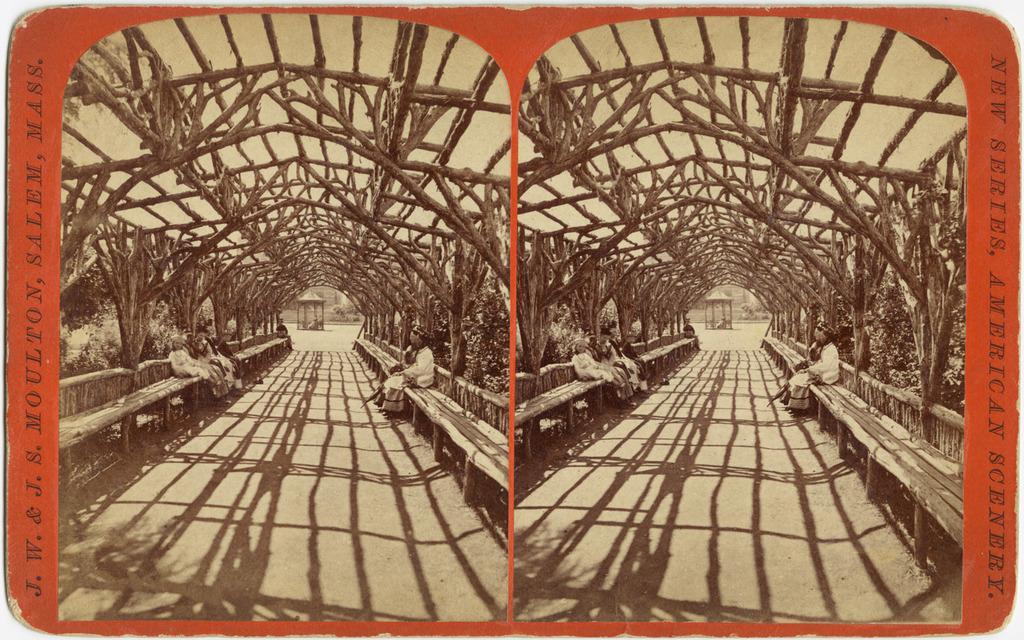Please provide a concise description of this image. This is a collage of same image. On the sides something is written. And on the image some people are sitting on wooden benches and there is an arch made with woods. Also there are trees. 